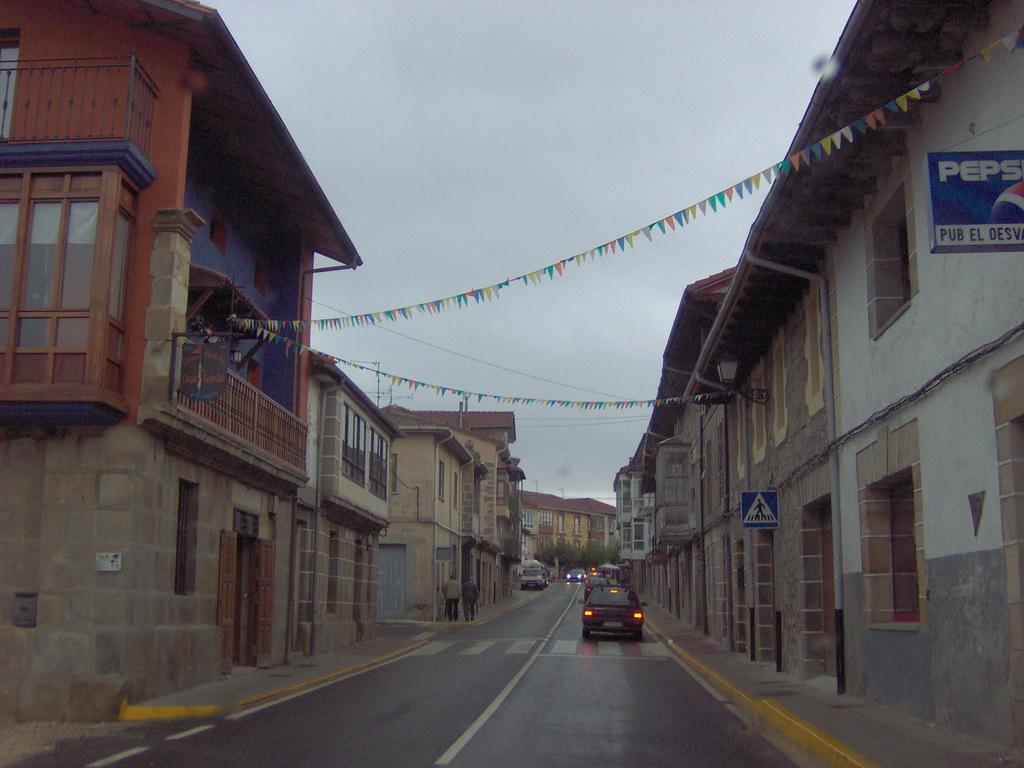Describe this image in one or two sentences. On the right side we can see some buildings and some persons walking. In the middle if the image we can see some cars, trees and sky. On the left side we can see some buildings, board of a pepsi and pedestrian cross. 